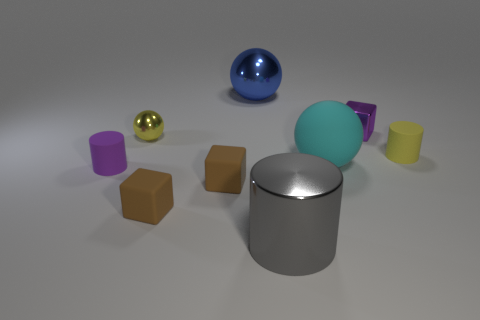There is a matte cylinder that is to the right of the small cylinder that is left of the yellow sphere; what is its color?
Give a very brief answer. Yellow. There is a cyan object that is the same shape as the large blue metallic object; what material is it?
Provide a succinct answer. Rubber. Are there any yellow metallic balls behind the purple cube?
Your answer should be very brief. No. What number of cyan matte things are there?
Provide a succinct answer. 1. There is a small yellow thing right of the cyan ball; how many metal things are in front of it?
Your answer should be very brief. 1. There is a tiny shiny block; is its color the same as the rubber cylinder that is in front of the big cyan rubber sphere?
Give a very brief answer. Yes. What number of other tiny yellow objects are the same shape as the yellow rubber thing?
Give a very brief answer. 0. There is a cylinder right of the purple metallic cube; what material is it?
Your response must be concise. Rubber. There is a shiny object that is in front of the yellow metal sphere; does it have the same shape as the tiny purple rubber object?
Offer a terse response. Yes. Is there a purple matte thing of the same size as the metallic block?
Ensure brevity in your answer.  Yes. 